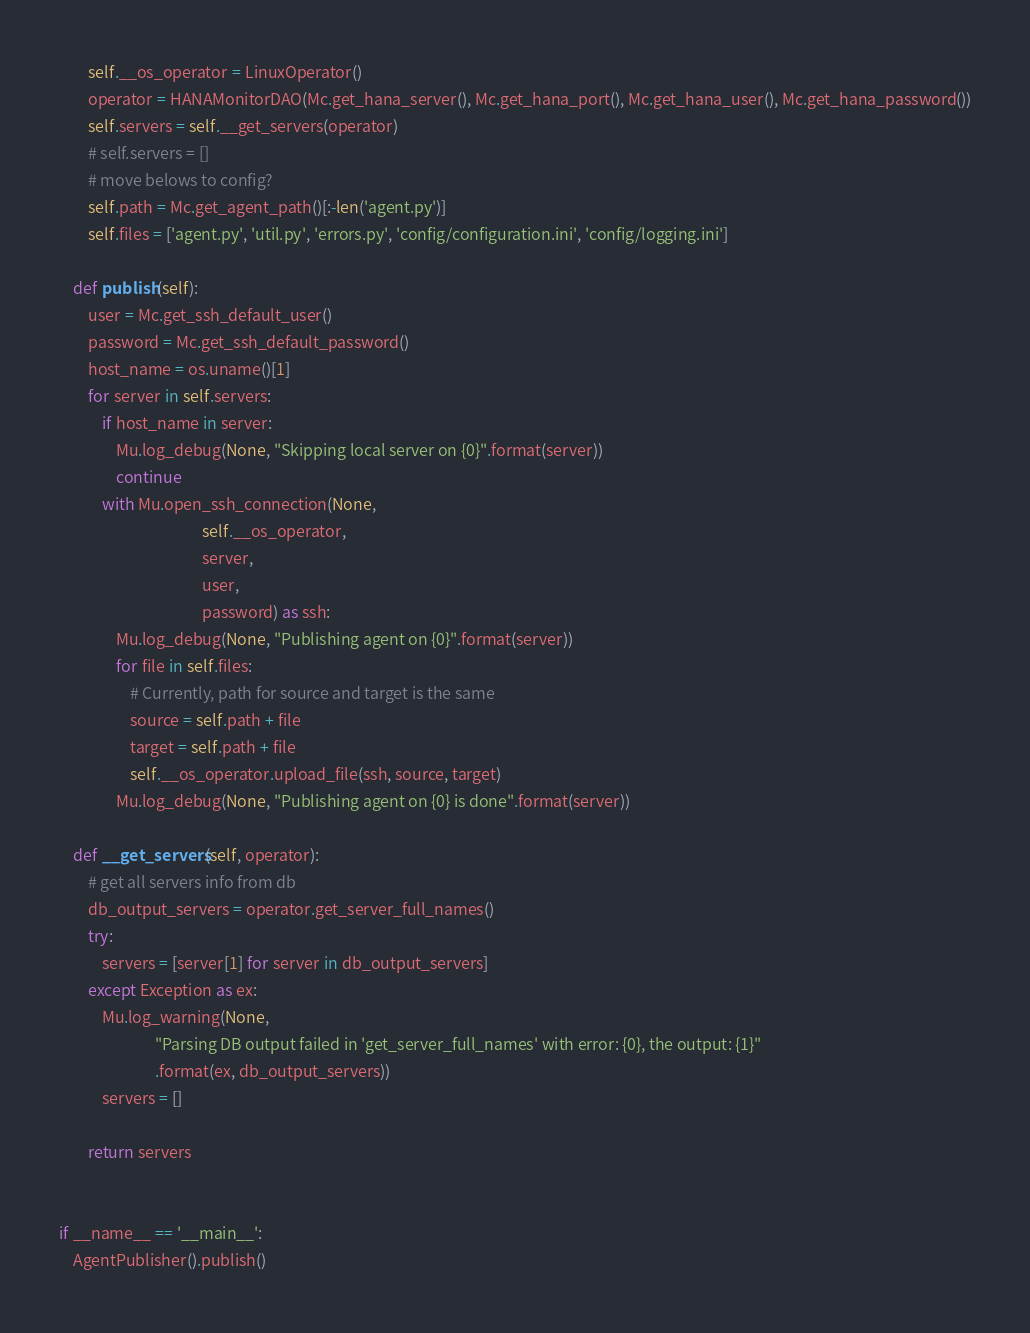<code> <loc_0><loc_0><loc_500><loc_500><_Python_>        self.__os_operator = LinuxOperator()
        operator = HANAMonitorDAO(Mc.get_hana_server(), Mc.get_hana_port(), Mc.get_hana_user(), Mc.get_hana_password())
        self.servers = self.__get_servers(operator)
        # self.servers = []
        # move belows to config?
        self.path = Mc.get_agent_path()[:-len('agent.py')]
        self.files = ['agent.py', 'util.py', 'errors.py', 'config/configuration.ini', 'config/logging.ini']

    def publish(self):
        user = Mc.get_ssh_default_user()
        password = Mc.get_ssh_default_password()
        host_name = os.uname()[1]
        for server in self.servers:
            if host_name in server:
                Mu.log_debug(None, "Skipping local server on {0}".format(server))
                continue
            with Mu.open_ssh_connection(None,
                                        self.__os_operator,
                                        server,
                                        user,
                                        password) as ssh:
                Mu.log_debug(None, "Publishing agent on {0}".format(server))
                for file in self.files:
                    # Currently, path for source and target is the same
                    source = self.path + file
                    target = self.path + file
                    self.__os_operator.upload_file(ssh, source, target)
                Mu.log_debug(None, "Publishing agent on {0} is done".format(server))

    def __get_servers(self, operator):
        # get all servers info from db
        db_output_servers = operator.get_server_full_names()
        try:
            servers = [server[1] for server in db_output_servers]
        except Exception as ex:
            Mu.log_warning(None,
                           "Parsing DB output failed in 'get_server_full_names' with error: {0}, the output: {1}"
                           .format(ex, db_output_servers))
            servers = []

        return servers


if __name__ == '__main__':
    AgentPublisher().publish()
</code> 